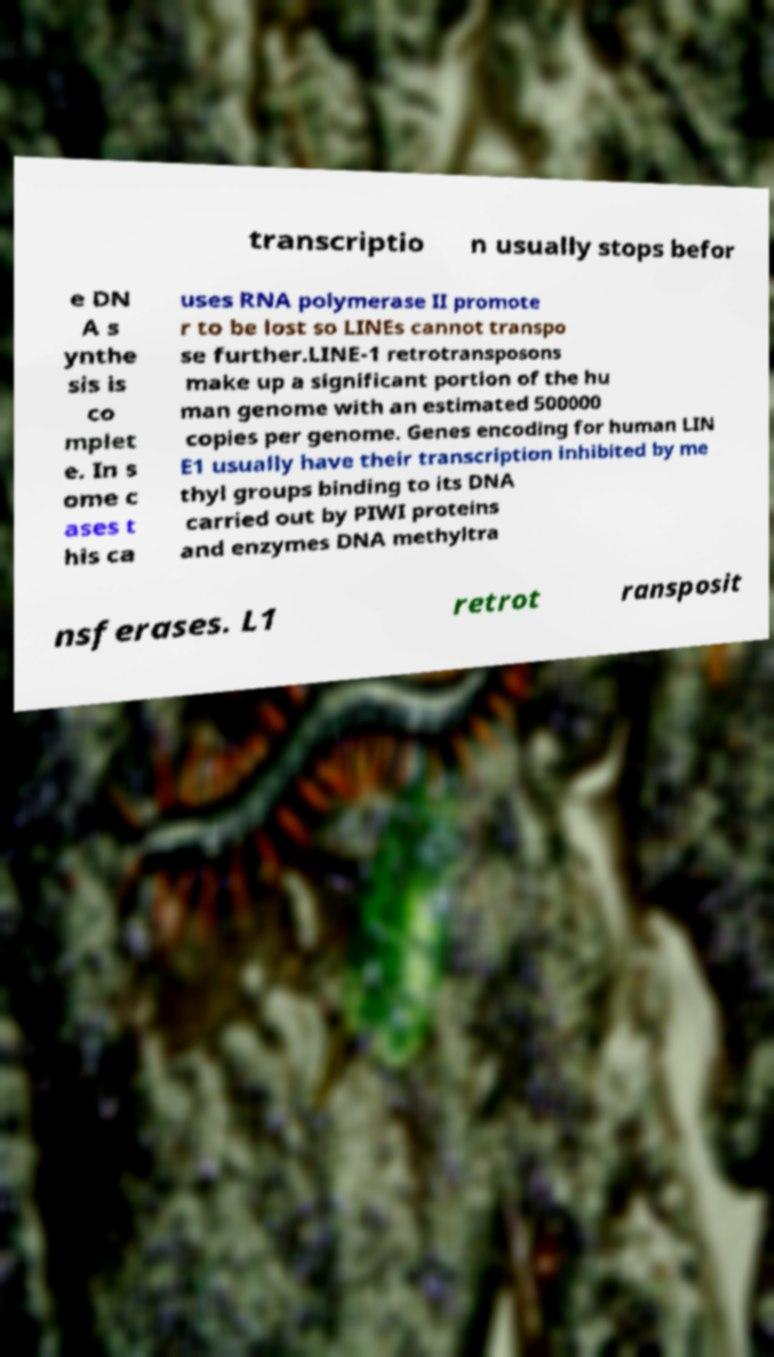For documentation purposes, I need the text within this image transcribed. Could you provide that? transcriptio n usually stops befor e DN A s ynthe sis is co mplet e. In s ome c ases t his ca uses RNA polymerase II promote r to be lost so LINEs cannot transpo se further.LINE-1 retrotransposons make up a significant portion of the hu man genome with an estimated 500000 copies per genome. Genes encoding for human LIN E1 usually have their transcription inhibited by me thyl groups binding to its DNA carried out by PIWI proteins and enzymes DNA methyltra nsferases. L1 retrot ransposit 